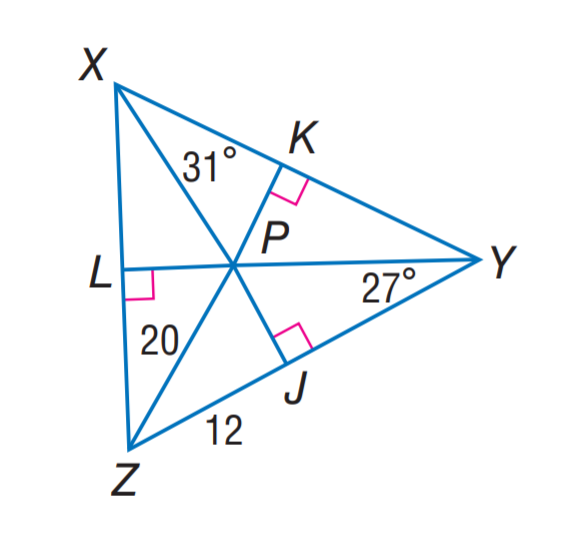Answer the mathemtical geometry problem and directly provide the correct option letter.
Question: P is the incenter of \angle X Y Z. Find P K.
Choices: A: 8 B: 12 C: 16 D: 20 C 